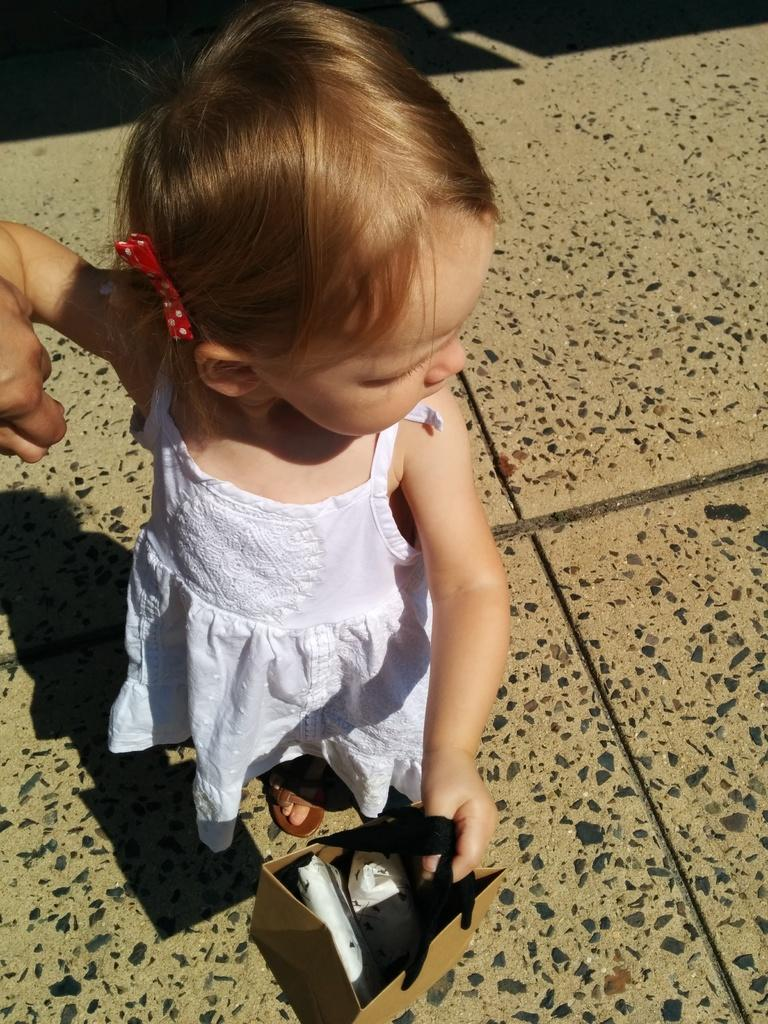Who is the main subject in the image? There is a girl in the image. What is the girl holding in the image? The girl is holding a bag. What type of surface is visible at the bottom of the image? There is floor visible at the bottom of the image. What subject is the girl teaching in the image? There is no indication in the image that the girl is teaching a subject. 